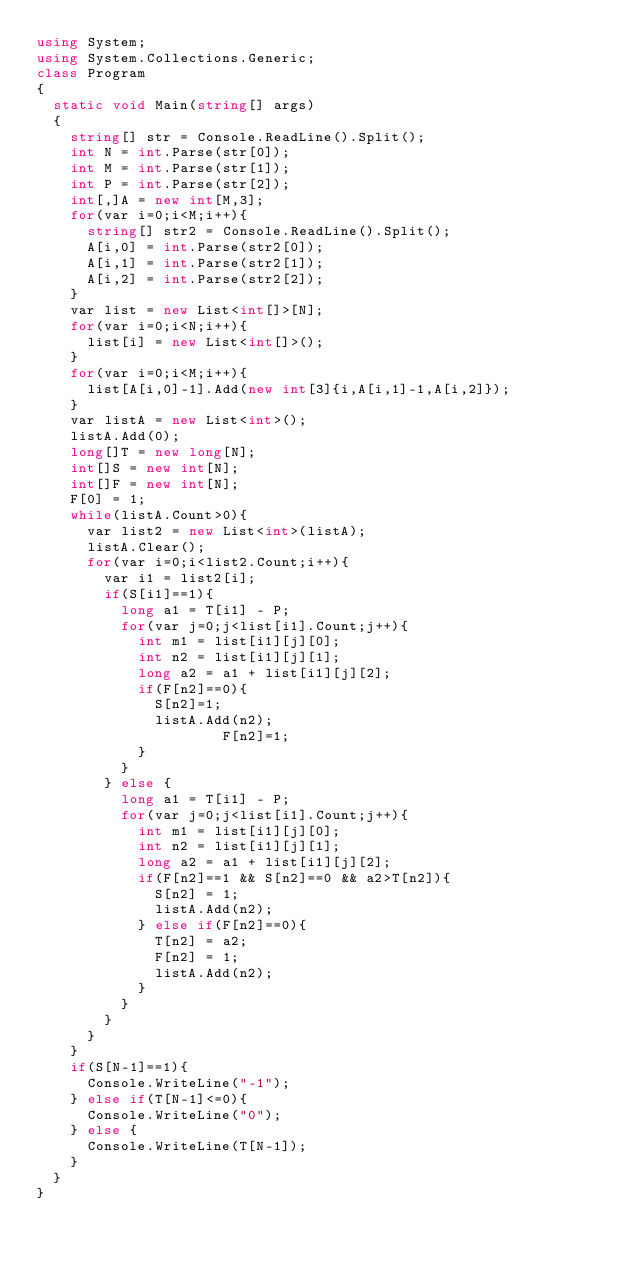Convert code to text. <code><loc_0><loc_0><loc_500><loc_500><_C#_>using System;
using System.Collections.Generic;
class Program
{
	static void Main(string[] args)
	{
		string[] str = Console.ReadLine().Split();
		int N = int.Parse(str[0]);
		int M = int.Parse(str[1]);
		int P = int.Parse(str[2]);
		int[,]A = new int[M,3];
		for(var i=0;i<M;i++){
			string[] str2 = Console.ReadLine().Split();
			A[i,0] = int.Parse(str2[0]);
			A[i,1] = int.Parse(str2[1]);
			A[i,2] = int.Parse(str2[2]);
		}
		var list = new List<int[]>[N];
		for(var i=0;i<N;i++){
			list[i] = new List<int[]>();
		}
		for(var i=0;i<M;i++){
			list[A[i,0]-1].Add(new int[3]{i,A[i,1]-1,A[i,2]});
		}
		var listA = new List<int>();
		listA.Add(0);
		long[]T = new long[N];
		int[]S = new int[N];
		int[]F = new int[N];
		F[0] = 1;
		while(listA.Count>0){
			var list2 = new List<int>(listA);
			listA.Clear();
			for(var i=0;i<list2.Count;i++){
				var i1 = list2[i];
				if(S[i1]==1){
					long a1 = T[i1] - P;
					for(var j=0;j<list[i1].Count;j++){
						int m1 = list[i1][j][0];
						int n2 = list[i1][j][1];
						long a2 = a1 + list[i1][j][2];
						if(F[n2]==0){
							S[n2]=1;
							listA.Add(n2);
                 			F[n2]=1;
						}
					}
				} else {
					long a1 = T[i1] - P;
					for(var j=0;j<list[i1].Count;j++){
						int m1 = list[i1][j][0];
						int n2 = list[i1][j][1];
						long a2 = a1 + list[i1][j][2];
						if(F[n2]==1 && S[n2]==0 && a2>T[n2]){
							S[n2] = 1;
							listA.Add(n2);
						} else if(F[n2]==0){
							T[n2] = a2;
							F[n2] = 1;
							listA.Add(n2);
						}
					}
				}
			}
		}
		if(S[N-1]==1){
			Console.WriteLine("-1");
		} else if(T[N-1]<=0){
			Console.WriteLine("0");
		} else {
			Console.WriteLine(T[N-1]);
		}
	}
}</code> 